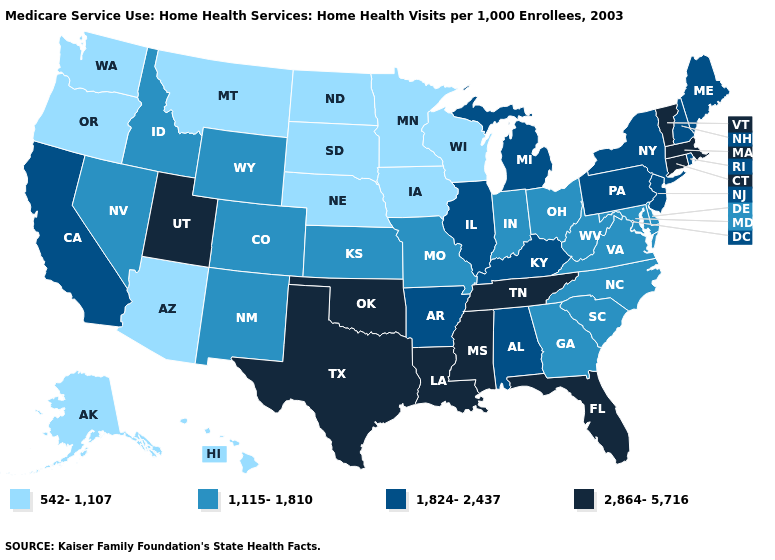What is the lowest value in states that border Pennsylvania?
Concise answer only. 1,115-1,810. Does Pennsylvania have the same value as Michigan?
Short answer required. Yes. What is the value of Pennsylvania?
Answer briefly. 1,824-2,437. What is the value of Iowa?
Concise answer only. 542-1,107. What is the value of Alabama?
Give a very brief answer. 1,824-2,437. What is the value of Michigan?
Write a very short answer. 1,824-2,437. Which states have the lowest value in the West?
Write a very short answer. Alaska, Arizona, Hawaii, Montana, Oregon, Washington. Name the states that have a value in the range 1,115-1,810?
Keep it brief. Colorado, Delaware, Georgia, Idaho, Indiana, Kansas, Maryland, Missouri, Nevada, New Mexico, North Carolina, Ohio, South Carolina, Virginia, West Virginia, Wyoming. What is the lowest value in the MidWest?
Keep it brief. 542-1,107. Which states hav the highest value in the MidWest?
Concise answer only. Illinois, Michigan. Name the states that have a value in the range 2,864-5,716?
Concise answer only. Connecticut, Florida, Louisiana, Massachusetts, Mississippi, Oklahoma, Tennessee, Texas, Utah, Vermont. Is the legend a continuous bar?
Concise answer only. No. Name the states that have a value in the range 1,824-2,437?
Concise answer only. Alabama, Arkansas, California, Illinois, Kentucky, Maine, Michigan, New Hampshire, New Jersey, New York, Pennsylvania, Rhode Island. What is the value of Kansas?
Short answer required. 1,115-1,810. What is the highest value in states that border Illinois?
Concise answer only. 1,824-2,437. 